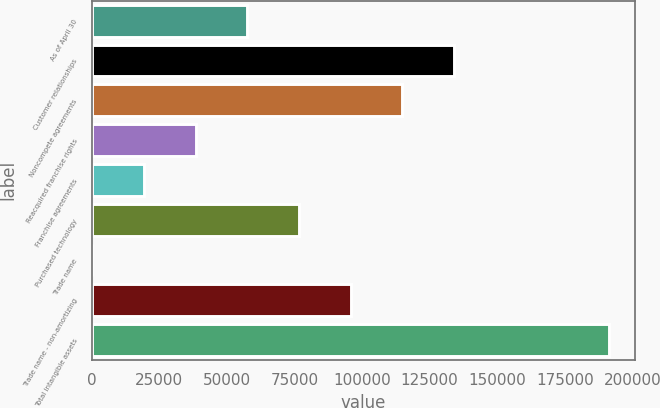Convert chart. <chart><loc_0><loc_0><loc_500><loc_500><bar_chart><fcel>As of April 30<fcel>Customer relationships<fcel>Noncompete agreements<fcel>Reacquired franchise rights<fcel>Franchise agreements<fcel>Purchased technology<fcel>Trade name<fcel>Trade name - non-amortizing<fcel>Total intangible assets<nl><fcel>57580.6<fcel>134065<fcel>114944<fcel>38459.4<fcel>19338.2<fcel>76701.8<fcel>217<fcel>95823<fcel>191429<nl></chart> 